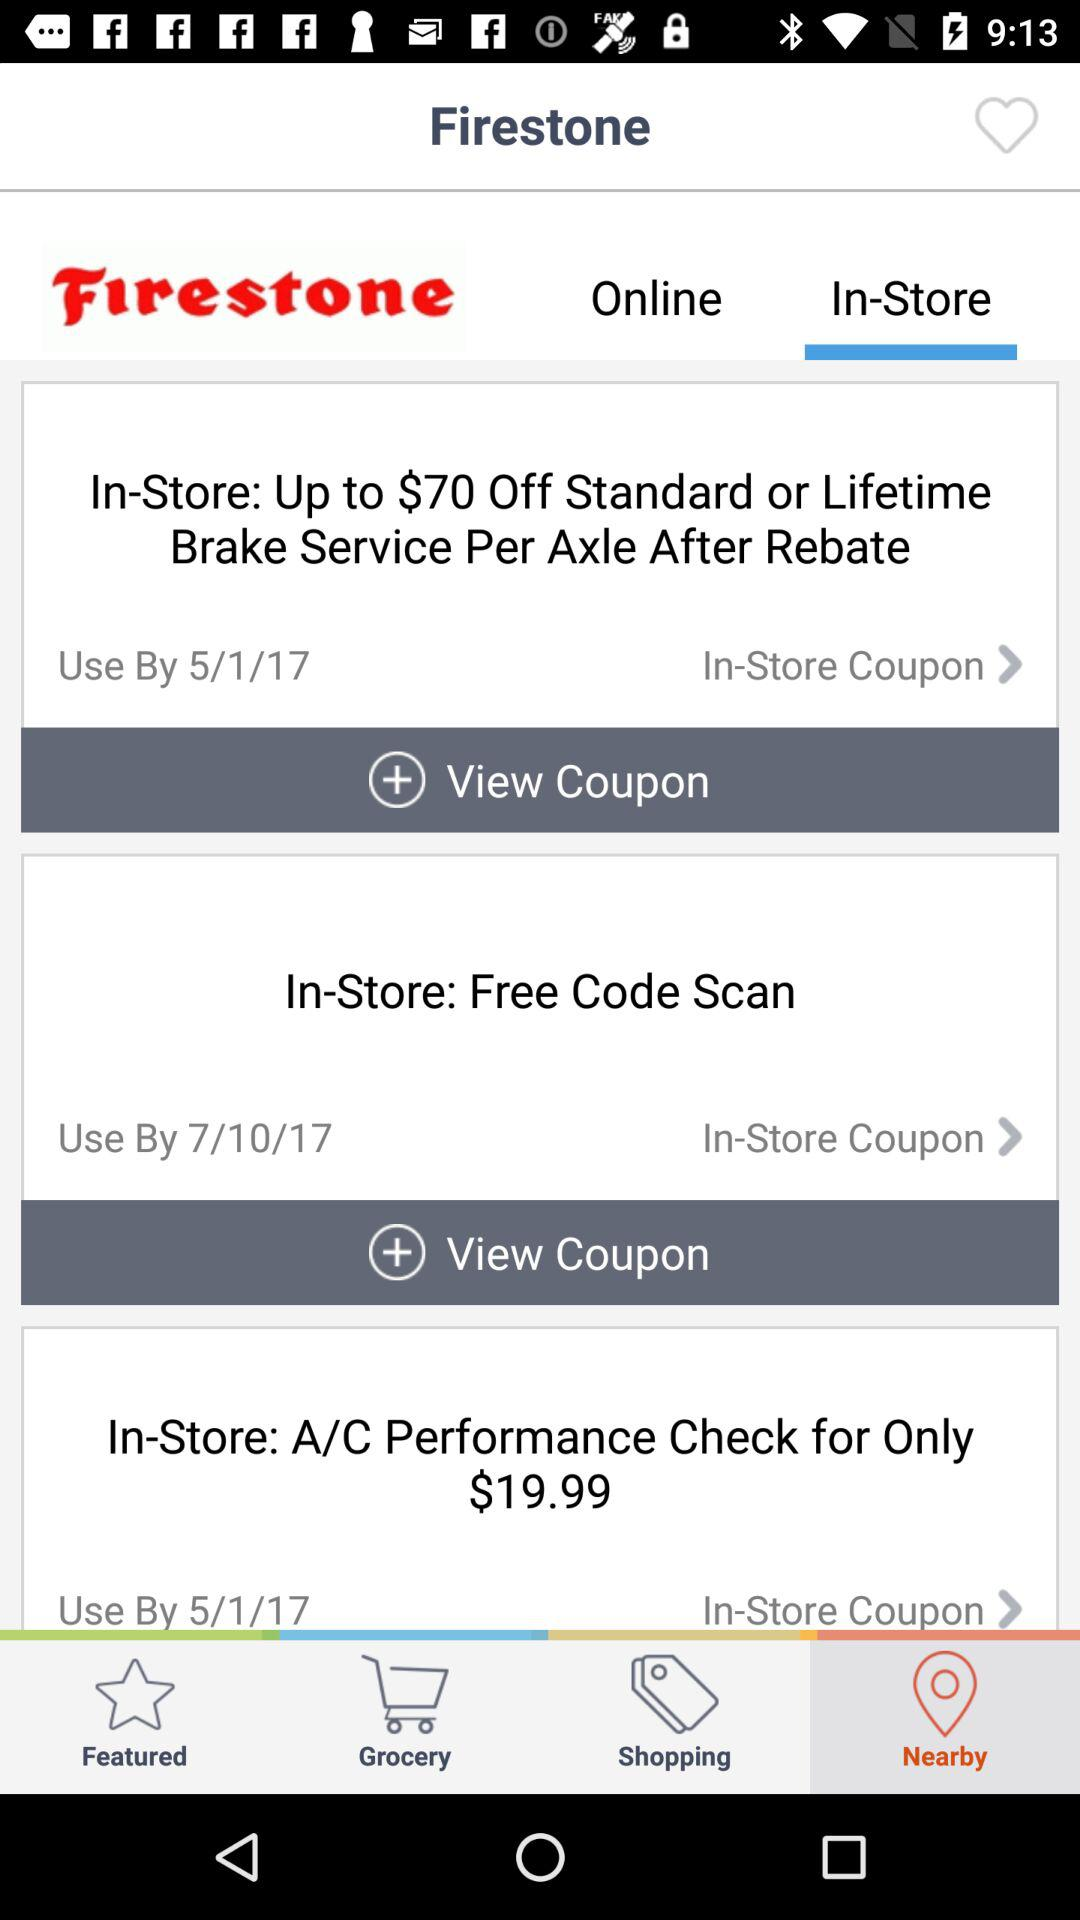What is the price for the A/C performance check? The price is $19.99. 